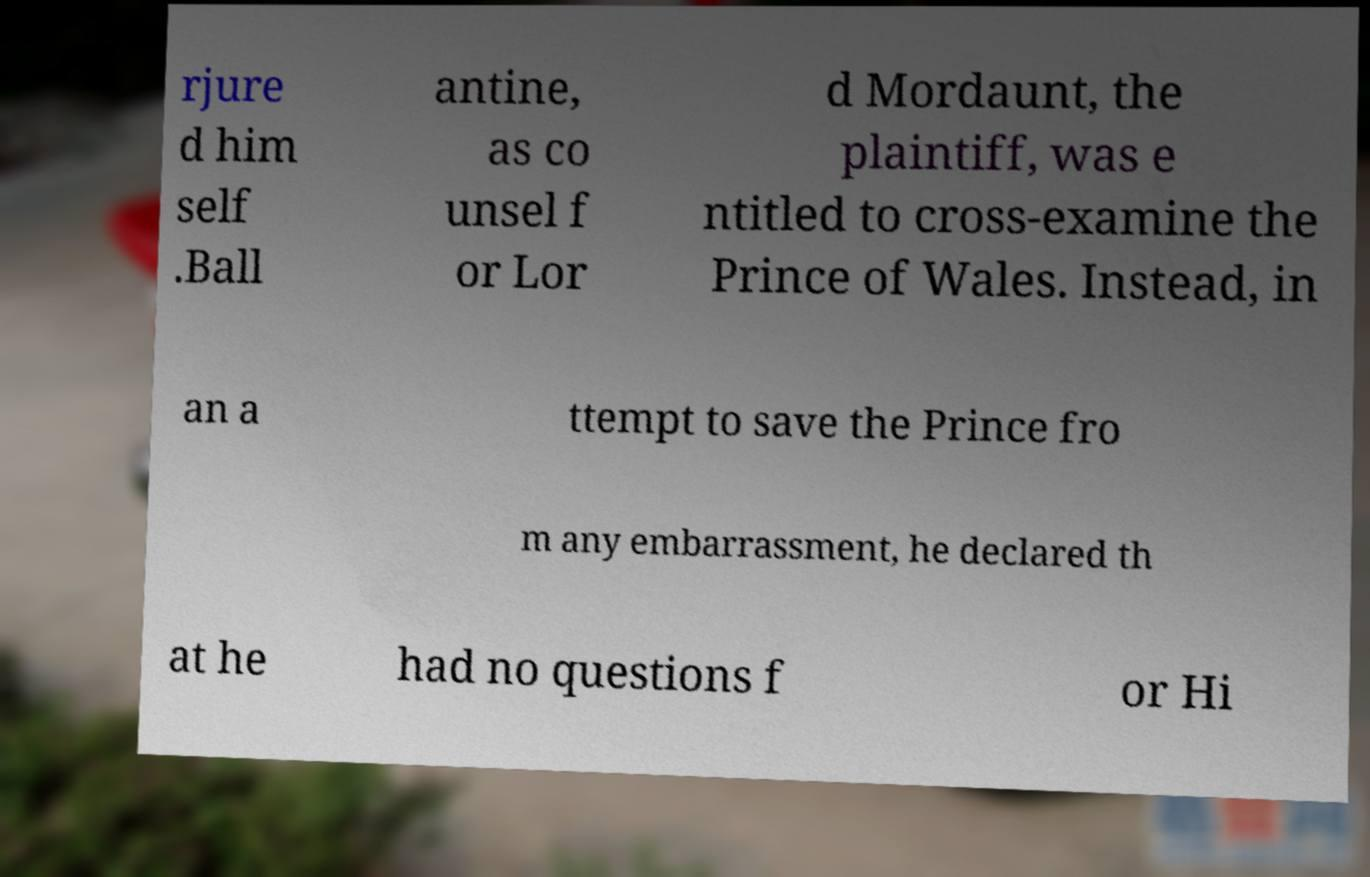Can you accurately transcribe the text from the provided image for me? rjure d him self .Ball antine, as co unsel f or Lor d Mordaunt, the plaintiff, was e ntitled to cross-examine the Prince of Wales. Instead, in an a ttempt to save the Prince fro m any embarrassment, he declared th at he had no questions f or Hi 